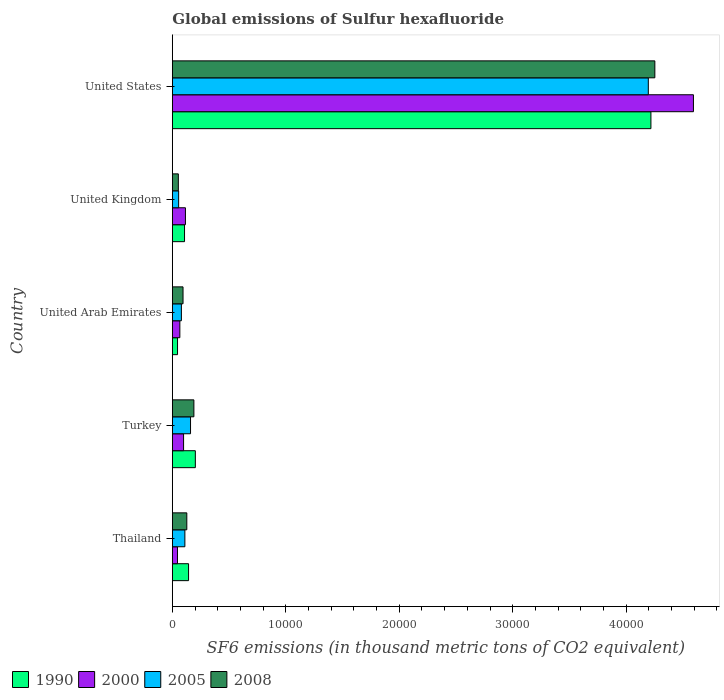How many groups of bars are there?
Your response must be concise. 5. Are the number of bars per tick equal to the number of legend labels?
Keep it short and to the point. Yes. Are the number of bars on each tick of the Y-axis equal?
Offer a very short reply. Yes. How many bars are there on the 1st tick from the top?
Your response must be concise. 4. How many bars are there on the 5th tick from the bottom?
Ensure brevity in your answer.  4. In how many cases, is the number of bars for a given country not equal to the number of legend labels?
Provide a short and direct response. 0. What is the global emissions of Sulfur hexafluoride in 2008 in United States?
Ensure brevity in your answer.  4.25e+04. Across all countries, what is the maximum global emissions of Sulfur hexafluoride in 1990?
Your answer should be compact. 4.22e+04. Across all countries, what is the minimum global emissions of Sulfur hexafluoride in 2000?
Your response must be concise. 453.1. In which country was the global emissions of Sulfur hexafluoride in 1990 maximum?
Your answer should be compact. United States. In which country was the global emissions of Sulfur hexafluoride in 1990 minimum?
Your answer should be compact. United Arab Emirates. What is the total global emissions of Sulfur hexafluoride in 2005 in the graph?
Your response must be concise. 4.60e+04. What is the difference between the global emissions of Sulfur hexafluoride in 2000 in Turkey and that in United Kingdom?
Offer a terse response. -164.9. What is the difference between the global emissions of Sulfur hexafluoride in 2008 in Thailand and the global emissions of Sulfur hexafluoride in 2005 in United Kingdom?
Give a very brief answer. 720.3. What is the average global emissions of Sulfur hexafluoride in 1990 per country?
Give a very brief answer. 9433.82. What is the difference between the global emissions of Sulfur hexafluoride in 1990 and global emissions of Sulfur hexafluoride in 2005 in United Kingdom?
Your response must be concise. 519.7. What is the ratio of the global emissions of Sulfur hexafluoride in 2008 in Turkey to that in United Arab Emirates?
Keep it short and to the point. 2.02. What is the difference between the highest and the second highest global emissions of Sulfur hexafluoride in 2000?
Offer a very short reply. 4.48e+04. What is the difference between the highest and the lowest global emissions of Sulfur hexafluoride in 2005?
Ensure brevity in your answer.  4.14e+04. In how many countries, is the global emissions of Sulfur hexafluoride in 2005 greater than the average global emissions of Sulfur hexafluoride in 2005 taken over all countries?
Offer a very short reply. 1. Is the sum of the global emissions of Sulfur hexafluoride in 2005 in Thailand and Turkey greater than the maximum global emissions of Sulfur hexafluoride in 2008 across all countries?
Give a very brief answer. No. What does the 4th bar from the top in Thailand represents?
Your response must be concise. 1990. What does the 2nd bar from the bottom in Turkey represents?
Keep it short and to the point. 2000. How many bars are there?
Provide a short and direct response. 20. How many countries are there in the graph?
Your response must be concise. 5. Are the values on the major ticks of X-axis written in scientific E-notation?
Provide a succinct answer. No. Does the graph contain grids?
Offer a terse response. No. How many legend labels are there?
Provide a short and direct response. 4. What is the title of the graph?
Your answer should be very brief. Global emissions of Sulfur hexafluoride. Does "1984" appear as one of the legend labels in the graph?
Give a very brief answer. No. What is the label or title of the X-axis?
Keep it short and to the point. SF6 emissions (in thousand metric tons of CO2 equivalent). What is the label or title of the Y-axis?
Your answer should be very brief. Country. What is the SF6 emissions (in thousand metric tons of CO2 equivalent) in 1990 in Thailand?
Provide a succinct answer. 1429.5. What is the SF6 emissions (in thousand metric tons of CO2 equivalent) in 2000 in Thailand?
Offer a terse response. 453.1. What is the SF6 emissions (in thousand metric tons of CO2 equivalent) in 2005 in Thailand?
Provide a succinct answer. 1103.9. What is the SF6 emissions (in thousand metric tons of CO2 equivalent) of 2008 in Thailand?
Offer a very short reply. 1274.5. What is the SF6 emissions (in thousand metric tons of CO2 equivalent) of 1990 in Turkey?
Give a very brief answer. 2027.1. What is the SF6 emissions (in thousand metric tons of CO2 equivalent) of 2000 in Turkey?
Offer a terse response. 989.2. What is the SF6 emissions (in thousand metric tons of CO2 equivalent) in 2005 in Turkey?
Offer a terse response. 1602.2. What is the SF6 emissions (in thousand metric tons of CO2 equivalent) in 2008 in Turkey?
Provide a short and direct response. 1898.8. What is the SF6 emissions (in thousand metric tons of CO2 equivalent) of 1990 in United Arab Emirates?
Ensure brevity in your answer.  456.1. What is the SF6 emissions (in thousand metric tons of CO2 equivalent) of 2000 in United Arab Emirates?
Offer a terse response. 660.1. What is the SF6 emissions (in thousand metric tons of CO2 equivalent) of 2005 in United Arab Emirates?
Offer a very short reply. 796.2. What is the SF6 emissions (in thousand metric tons of CO2 equivalent) in 2008 in United Arab Emirates?
Offer a very short reply. 941.4. What is the SF6 emissions (in thousand metric tons of CO2 equivalent) in 1990 in United Kingdom?
Give a very brief answer. 1073.9. What is the SF6 emissions (in thousand metric tons of CO2 equivalent) of 2000 in United Kingdom?
Provide a succinct answer. 1154.1. What is the SF6 emissions (in thousand metric tons of CO2 equivalent) of 2005 in United Kingdom?
Keep it short and to the point. 554.2. What is the SF6 emissions (in thousand metric tons of CO2 equivalent) in 2008 in United Kingdom?
Provide a succinct answer. 528.9. What is the SF6 emissions (in thousand metric tons of CO2 equivalent) of 1990 in United States?
Offer a very short reply. 4.22e+04. What is the SF6 emissions (in thousand metric tons of CO2 equivalent) of 2000 in United States?
Ensure brevity in your answer.  4.59e+04. What is the SF6 emissions (in thousand metric tons of CO2 equivalent) of 2005 in United States?
Make the answer very short. 4.20e+04. What is the SF6 emissions (in thousand metric tons of CO2 equivalent) in 2008 in United States?
Your answer should be compact. 4.25e+04. Across all countries, what is the maximum SF6 emissions (in thousand metric tons of CO2 equivalent) in 1990?
Provide a short and direct response. 4.22e+04. Across all countries, what is the maximum SF6 emissions (in thousand metric tons of CO2 equivalent) of 2000?
Provide a succinct answer. 4.59e+04. Across all countries, what is the maximum SF6 emissions (in thousand metric tons of CO2 equivalent) of 2005?
Offer a terse response. 4.20e+04. Across all countries, what is the maximum SF6 emissions (in thousand metric tons of CO2 equivalent) in 2008?
Keep it short and to the point. 4.25e+04. Across all countries, what is the minimum SF6 emissions (in thousand metric tons of CO2 equivalent) in 1990?
Provide a short and direct response. 456.1. Across all countries, what is the minimum SF6 emissions (in thousand metric tons of CO2 equivalent) of 2000?
Ensure brevity in your answer.  453.1. Across all countries, what is the minimum SF6 emissions (in thousand metric tons of CO2 equivalent) of 2005?
Provide a succinct answer. 554.2. Across all countries, what is the minimum SF6 emissions (in thousand metric tons of CO2 equivalent) of 2008?
Offer a very short reply. 528.9. What is the total SF6 emissions (in thousand metric tons of CO2 equivalent) of 1990 in the graph?
Ensure brevity in your answer.  4.72e+04. What is the total SF6 emissions (in thousand metric tons of CO2 equivalent) in 2000 in the graph?
Give a very brief answer. 4.92e+04. What is the total SF6 emissions (in thousand metric tons of CO2 equivalent) of 2005 in the graph?
Ensure brevity in your answer.  4.60e+04. What is the total SF6 emissions (in thousand metric tons of CO2 equivalent) of 2008 in the graph?
Your response must be concise. 4.72e+04. What is the difference between the SF6 emissions (in thousand metric tons of CO2 equivalent) in 1990 in Thailand and that in Turkey?
Provide a succinct answer. -597.6. What is the difference between the SF6 emissions (in thousand metric tons of CO2 equivalent) of 2000 in Thailand and that in Turkey?
Provide a short and direct response. -536.1. What is the difference between the SF6 emissions (in thousand metric tons of CO2 equivalent) of 2005 in Thailand and that in Turkey?
Your response must be concise. -498.3. What is the difference between the SF6 emissions (in thousand metric tons of CO2 equivalent) in 2008 in Thailand and that in Turkey?
Make the answer very short. -624.3. What is the difference between the SF6 emissions (in thousand metric tons of CO2 equivalent) of 1990 in Thailand and that in United Arab Emirates?
Give a very brief answer. 973.4. What is the difference between the SF6 emissions (in thousand metric tons of CO2 equivalent) of 2000 in Thailand and that in United Arab Emirates?
Provide a short and direct response. -207. What is the difference between the SF6 emissions (in thousand metric tons of CO2 equivalent) of 2005 in Thailand and that in United Arab Emirates?
Keep it short and to the point. 307.7. What is the difference between the SF6 emissions (in thousand metric tons of CO2 equivalent) in 2008 in Thailand and that in United Arab Emirates?
Provide a short and direct response. 333.1. What is the difference between the SF6 emissions (in thousand metric tons of CO2 equivalent) in 1990 in Thailand and that in United Kingdom?
Offer a very short reply. 355.6. What is the difference between the SF6 emissions (in thousand metric tons of CO2 equivalent) of 2000 in Thailand and that in United Kingdom?
Ensure brevity in your answer.  -701. What is the difference between the SF6 emissions (in thousand metric tons of CO2 equivalent) in 2005 in Thailand and that in United Kingdom?
Offer a very short reply. 549.7. What is the difference between the SF6 emissions (in thousand metric tons of CO2 equivalent) in 2008 in Thailand and that in United Kingdom?
Keep it short and to the point. 745.6. What is the difference between the SF6 emissions (in thousand metric tons of CO2 equivalent) of 1990 in Thailand and that in United States?
Ensure brevity in your answer.  -4.08e+04. What is the difference between the SF6 emissions (in thousand metric tons of CO2 equivalent) in 2000 in Thailand and that in United States?
Your answer should be compact. -4.55e+04. What is the difference between the SF6 emissions (in thousand metric tons of CO2 equivalent) in 2005 in Thailand and that in United States?
Your response must be concise. -4.08e+04. What is the difference between the SF6 emissions (in thousand metric tons of CO2 equivalent) of 2008 in Thailand and that in United States?
Your answer should be very brief. -4.13e+04. What is the difference between the SF6 emissions (in thousand metric tons of CO2 equivalent) in 1990 in Turkey and that in United Arab Emirates?
Your response must be concise. 1571. What is the difference between the SF6 emissions (in thousand metric tons of CO2 equivalent) in 2000 in Turkey and that in United Arab Emirates?
Offer a very short reply. 329.1. What is the difference between the SF6 emissions (in thousand metric tons of CO2 equivalent) of 2005 in Turkey and that in United Arab Emirates?
Make the answer very short. 806. What is the difference between the SF6 emissions (in thousand metric tons of CO2 equivalent) in 2008 in Turkey and that in United Arab Emirates?
Ensure brevity in your answer.  957.4. What is the difference between the SF6 emissions (in thousand metric tons of CO2 equivalent) of 1990 in Turkey and that in United Kingdom?
Your answer should be very brief. 953.2. What is the difference between the SF6 emissions (in thousand metric tons of CO2 equivalent) in 2000 in Turkey and that in United Kingdom?
Keep it short and to the point. -164.9. What is the difference between the SF6 emissions (in thousand metric tons of CO2 equivalent) in 2005 in Turkey and that in United Kingdom?
Provide a succinct answer. 1048. What is the difference between the SF6 emissions (in thousand metric tons of CO2 equivalent) in 2008 in Turkey and that in United Kingdom?
Make the answer very short. 1369.9. What is the difference between the SF6 emissions (in thousand metric tons of CO2 equivalent) of 1990 in Turkey and that in United States?
Make the answer very short. -4.02e+04. What is the difference between the SF6 emissions (in thousand metric tons of CO2 equivalent) in 2000 in Turkey and that in United States?
Give a very brief answer. -4.49e+04. What is the difference between the SF6 emissions (in thousand metric tons of CO2 equivalent) in 2005 in Turkey and that in United States?
Give a very brief answer. -4.04e+04. What is the difference between the SF6 emissions (in thousand metric tons of CO2 equivalent) in 2008 in Turkey and that in United States?
Provide a succinct answer. -4.06e+04. What is the difference between the SF6 emissions (in thousand metric tons of CO2 equivalent) of 1990 in United Arab Emirates and that in United Kingdom?
Keep it short and to the point. -617.8. What is the difference between the SF6 emissions (in thousand metric tons of CO2 equivalent) in 2000 in United Arab Emirates and that in United Kingdom?
Your response must be concise. -494. What is the difference between the SF6 emissions (in thousand metric tons of CO2 equivalent) in 2005 in United Arab Emirates and that in United Kingdom?
Offer a terse response. 242. What is the difference between the SF6 emissions (in thousand metric tons of CO2 equivalent) of 2008 in United Arab Emirates and that in United Kingdom?
Your answer should be very brief. 412.5. What is the difference between the SF6 emissions (in thousand metric tons of CO2 equivalent) of 1990 in United Arab Emirates and that in United States?
Offer a very short reply. -4.17e+04. What is the difference between the SF6 emissions (in thousand metric tons of CO2 equivalent) of 2000 in United Arab Emirates and that in United States?
Provide a short and direct response. -4.53e+04. What is the difference between the SF6 emissions (in thousand metric tons of CO2 equivalent) of 2005 in United Arab Emirates and that in United States?
Provide a succinct answer. -4.12e+04. What is the difference between the SF6 emissions (in thousand metric tons of CO2 equivalent) of 2008 in United Arab Emirates and that in United States?
Your answer should be compact. -4.16e+04. What is the difference between the SF6 emissions (in thousand metric tons of CO2 equivalent) in 1990 in United Kingdom and that in United States?
Offer a terse response. -4.11e+04. What is the difference between the SF6 emissions (in thousand metric tons of CO2 equivalent) of 2000 in United Kingdom and that in United States?
Provide a short and direct response. -4.48e+04. What is the difference between the SF6 emissions (in thousand metric tons of CO2 equivalent) of 2005 in United Kingdom and that in United States?
Your response must be concise. -4.14e+04. What is the difference between the SF6 emissions (in thousand metric tons of CO2 equivalent) of 2008 in United Kingdom and that in United States?
Offer a terse response. -4.20e+04. What is the difference between the SF6 emissions (in thousand metric tons of CO2 equivalent) in 1990 in Thailand and the SF6 emissions (in thousand metric tons of CO2 equivalent) in 2000 in Turkey?
Your response must be concise. 440.3. What is the difference between the SF6 emissions (in thousand metric tons of CO2 equivalent) in 1990 in Thailand and the SF6 emissions (in thousand metric tons of CO2 equivalent) in 2005 in Turkey?
Offer a terse response. -172.7. What is the difference between the SF6 emissions (in thousand metric tons of CO2 equivalent) of 1990 in Thailand and the SF6 emissions (in thousand metric tons of CO2 equivalent) of 2008 in Turkey?
Provide a short and direct response. -469.3. What is the difference between the SF6 emissions (in thousand metric tons of CO2 equivalent) in 2000 in Thailand and the SF6 emissions (in thousand metric tons of CO2 equivalent) in 2005 in Turkey?
Provide a succinct answer. -1149.1. What is the difference between the SF6 emissions (in thousand metric tons of CO2 equivalent) of 2000 in Thailand and the SF6 emissions (in thousand metric tons of CO2 equivalent) of 2008 in Turkey?
Your answer should be very brief. -1445.7. What is the difference between the SF6 emissions (in thousand metric tons of CO2 equivalent) of 2005 in Thailand and the SF6 emissions (in thousand metric tons of CO2 equivalent) of 2008 in Turkey?
Your answer should be very brief. -794.9. What is the difference between the SF6 emissions (in thousand metric tons of CO2 equivalent) of 1990 in Thailand and the SF6 emissions (in thousand metric tons of CO2 equivalent) of 2000 in United Arab Emirates?
Your answer should be very brief. 769.4. What is the difference between the SF6 emissions (in thousand metric tons of CO2 equivalent) of 1990 in Thailand and the SF6 emissions (in thousand metric tons of CO2 equivalent) of 2005 in United Arab Emirates?
Keep it short and to the point. 633.3. What is the difference between the SF6 emissions (in thousand metric tons of CO2 equivalent) in 1990 in Thailand and the SF6 emissions (in thousand metric tons of CO2 equivalent) in 2008 in United Arab Emirates?
Your response must be concise. 488.1. What is the difference between the SF6 emissions (in thousand metric tons of CO2 equivalent) of 2000 in Thailand and the SF6 emissions (in thousand metric tons of CO2 equivalent) of 2005 in United Arab Emirates?
Your answer should be compact. -343.1. What is the difference between the SF6 emissions (in thousand metric tons of CO2 equivalent) of 2000 in Thailand and the SF6 emissions (in thousand metric tons of CO2 equivalent) of 2008 in United Arab Emirates?
Your answer should be very brief. -488.3. What is the difference between the SF6 emissions (in thousand metric tons of CO2 equivalent) in 2005 in Thailand and the SF6 emissions (in thousand metric tons of CO2 equivalent) in 2008 in United Arab Emirates?
Give a very brief answer. 162.5. What is the difference between the SF6 emissions (in thousand metric tons of CO2 equivalent) in 1990 in Thailand and the SF6 emissions (in thousand metric tons of CO2 equivalent) in 2000 in United Kingdom?
Provide a short and direct response. 275.4. What is the difference between the SF6 emissions (in thousand metric tons of CO2 equivalent) in 1990 in Thailand and the SF6 emissions (in thousand metric tons of CO2 equivalent) in 2005 in United Kingdom?
Offer a very short reply. 875.3. What is the difference between the SF6 emissions (in thousand metric tons of CO2 equivalent) in 1990 in Thailand and the SF6 emissions (in thousand metric tons of CO2 equivalent) in 2008 in United Kingdom?
Give a very brief answer. 900.6. What is the difference between the SF6 emissions (in thousand metric tons of CO2 equivalent) of 2000 in Thailand and the SF6 emissions (in thousand metric tons of CO2 equivalent) of 2005 in United Kingdom?
Ensure brevity in your answer.  -101.1. What is the difference between the SF6 emissions (in thousand metric tons of CO2 equivalent) of 2000 in Thailand and the SF6 emissions (in thousand metric tons of CO2 equivalent) of 2008 in United Kingdom?
Your answer should be very brief. -75.8. What is the difference between the SF6 emissions (in thousand metric tons of CO2 equivalent) in 2005 in Thailand and the SF6 emissions (in thousand metric tons of CO2 equivalent) in 2008 in United Kingdom?
Ensure brevity in your answer.  575. What is the difference between the SF6 emissions (in thousand metric tons of CO2 equivalent) in 1990 in Thailand and the SF6 emissions (in thousand metric tons of CO2 equivalent) in 2000 in United States?
Keep it short and to the point. -4.45e+04. What is the difference between the SF6 emissions (in thousand metric tons of CO2 equivalent) in 1990 in Thailand and the SF6 emissions (in thousand metric tons of CO2 equivalent) in 2005 in United States?
Give a very brief answer. -4.05e+04. What is the difference between the SF6 emissions (in thousand metric tons of CO2 equivalent) of 1990 in Thailand and the SF6 emissions (in thousand metric tons of CO2 equivalent) of 2008 in United States?
Make the answer very short. -4.11e+04. What is the difference between the SF6 emissions (in thousand metric tons of CO2 equivalent) of 2000 in Thailand and the SF6 emissions (in thousand metric tons of CO2 equivalent) of 2005 in United States?
Make the answer very short. -4.15e+04. What is the difference between the SF6 emissions (in thousand metric tons of CO2 equivalent) in 2000 in Thailand and the SF6 emissions (in thousand metric tons of CO2 equivalent) in 2008 in United States?
Ensure brevity in your answer.  -4.21e+04. What is the difference between the SF6 emissions (in thousand metric tons of CO2 equivalent) in 2005 in Thailand and the SF6 emissions (in thousand metric tons of CO2 equivalent) in 2008 in United States?
Your response must be concise. -4.14e+04. What is the difference between the SF6 emissions (in thousand metric tons of CO2 equivalent) of 1990 in Turkey and the SF6 emissions (in thousand metric tons of CO2 equivalent) of 2000 in United Arab Emirates?
Your response must be concise. 1367. What is the difference between the SF6 emissions (in thousand metric tons of CO2 equivalent) in 1990 in Turkey and the SF6 emissions (in thousand metric tons of CO2 equivalent) in 2005 in United Arab Emirates?
Provide a succinct answer. 1230.9. What is the difference between the SF6 emissions (in thousand metric tons of CO2 equivalent) in 1990 in Turkey and the SF6 emissions (in thousand metric tons of CO2 equivalent) in 2008 in United Arab Emirates?
Provide a succinct answer. 1085.7. What is the difference between the SF6 emissions (in thousand metric tons of CO2 equivalent) of 2000 in Turkey and the SF6 emissions (in thousand metric tons of CO2 equivalent) of 2005 in United Arab Emirates?
Your answer should be compact. 193. What is the difference between the SF6 emissions (in thousand metric tons of CO2 equivalent) of 2000 in Turkey and the SF6 emissions (in thousand metric tons of CO2 equivalent) of 2008 in United Arab Emirates?
Offer a very short reply. 47.8. What is the difference between the SF6 emissions (in thousand metric tons of CO2 equivalent) in 2005 in Turkey and the SF6 emissions (in thousand metric tons of CO2 equivalent) in 2008 in United Arab Emirates?
Your response must be concise. 660.8. What is the difference between the SF6 emissions (in thousand metric tons of CO2 equivalent) of 1990 in Turkey and the SF6 emissions (in thousand metric tons of CO2 equivalent) of 2000 in United Kingdom?
Your answer should be very brief. 873. What is the difference between the SF6 emissions (in thousand metric tons of CO2 equivalent) in 1990 in Turkey and the SF6 emissions (in thousand metric tons of CO2 equivalent) in 2005 in United Kingdom?
Offer a very short reply. 1472.9. What is the difference between the SF6 emissions (in thousand metric tons of CO2 equivalent) of 1990 in Turkey and the SF6 emissions (in thousand metric tons of CO2 equivalent) of 2008 in United Kingdom?
Ensure brevity in your answer.  1498.2. What is the difference between the SF6 emissions (in thousand metric tons of CO2 equivalent) of 2000 in Turkey and the SF6 emissions (in thousand metric tons of CO2 equivalent) of 2005 in United Kingdom?
Your answer should be compact. 435. What is the difference between the SF6 emissions (in thousand metric tons of CO2 equivalent) of 2000 in Turkey and the SF6 emissions (in thousand metric tons of CO2 equivalent) of 2008 in United Kingdom?
Your answer should be compact. 460.3. What is the difference between the SF6 emissions (in thousand metric tons of CO2 equivalent) in 2005 in Turkey and the SF6 emissions (in thousand metric tons of CO2 equivalent) in 2008 in United Kingdom?
Give a very brief answer. 1073.3. What is the difference between the SF6 emissions (in thousand metric tons of CO2 equivalent) in 1990 in Turkey and the SF6 emissions (in thousand metric tons of CO2 equivalent) in 2000 in United States?
Your answer should be very brief. -4.39e+04. What is the difference between the SF6 emissions (in thousand metric tons of CO2 equivalent) in 1990 in Turkey and the SF6 emissions (in thousand metric tons of CO2 equivalent) in 2005 in United States?
Provide a short and direct response. -3.99e+04. What is the difference between the SF6 emissions (in thousand metric tons of CO2 equivalent) in 1990 in Turkey and the SF6 emissions (in thousand metric tons of CO2 equivalent) in 2008 in United States?
Provide a succinct answer. -4.05e+04. What is the difference between the SF6 emissions (in thousand metric tons of CO2 equivalent) in 2000 in Turkey and the SF6 emissions (in thousand metric tons of CO2 equivalent) in 2005 in United States?
Ensure brevity in your answer.  -4.10e+04. What is the difference between the SF6 emissions (in thousand metric tons of CO2 equivalent) in 2000 in Turkey and the SF6 emissions (in thousand metric tons of CO2 equivalent) in 2008 in United States?
Keep it short and to the point. -4.15e+04. What is the difference between the SF6 emissions (in thousand metric tons of CO2 equivalent) in 2005 in Turkey and the SF6 emissions (in thousand metric tons of CO2 equivalent) in 2008 in United States?
Provide a succinct answer. -4.09e+04. What is the difference between the SF6 emissions (in thousand metric tons of CO2 equivalent) of 1990 in United Arab Emirates and the SF6 emissions (in thousand metric tons of CO2 equivalent) of 2000 in United Kingdom?
Provide a short and direct response. -698. What is the difference between the SF6 emissions (in thousand metric tons of CO2 equivalent) of 1990 in United Arab Emirates and the SF6 emissions (in thousand metric tons of CO2 equivalent) of 2005 in United Kingdom?
Your answer should be very brief. -98.1. What is the difference between the SF6 emissions (in thousand metric tons of CO2 equivalent) in 1990 in United Arab Emirates and the SF6 emissions (in thousand metric tons of CO2 equivalent) in 2008 in United Kingdom?
Ensure brevity in your answer.  -72.8. What is the difference between the SF6 emissions (in thousand metric tons of CO2 equivalent) in 2000 in United Arab Emirates and the SF6 emissions (in thousand metric tons of CO2 equivalent) in 2005 in United Kingdom?
Make the answer very short. 105.9. What is the difference between the SF6 emissions (in thousand metric tons of CO2 equivalent) of 2000 in United Arab Emirates and the SF6 emissions (in thousand metric tons of CO2 equivalent) of 2008 in United Kingdom?
Make the answer very short. 131.2. What is the difference between the SF6 emissions (in thousand metric tons of CO2 equivalent) of 2005 in United Arab Emirates and the SF6 emissions (in thousand metric tons of CO2 equivalent) of 2008 in United Kingdom?
Ensure brevity in your answer.  267.3. What is the difference between the SF6 emissions (in thousand metric tons of CO2 equivalent) in 1990 in United Arab Emirates and the SF6 emissions (in thousand metric tons of CO2 equivalent) in 2000 in United States?
Give a very brief answer. -4.55e+04. What is the difference between the SF6 emissions (in thousand metric tons of CO2 equivalent) in 1990 in United Arab Emirates and the SF6 emissions (in thousand metric tons of CO2 equivalent) in 2005 in United States?
Your response must be concise. -4.15e+04. What is the difference between the SF6 emissions (in thousand metric tons of CO2 equivalent) of 1990 in United Arab Emirates and the SF6 emissions (in thousand metric tons of CO2 equivalent) of 2008 in United States?
Make the answer very short. -4.21e+04. What is the difference between the SF6 emissions (in thousand metric tons of CO2 equivalent) of 2000 in United Arab Emirates and the SF6 emissions (in thousand metric tons of CO2 equivalent) of 2005 in United States?
Ensure brevity in your answer.  -4.13e+04. What is the difference between the SF6 emissions (in thousand metric tons of CO2 equivalent) of 2000 in United Arab Emirates and the SF6 emissions (in thousand metric tons of CO2 equivalent) of 2008 in United States?
Keep it short and to the point. -4.19e+04. What is the difference between the SF6 emissions (in thousand metric tons of CO2 equivalent) of 2005 in United Arab Emirates and the SF6 emissions (in thousand metric tons of CO2 equivalent) of 2008 in United States?
Offer a terse response. -4.17e+04. What is the difference between the SF6 emissions (in thousand metric tons of CO2 equivalent) in 1990 in United Kingdom and the SF6 emissions (in thousand metric tons of CO2 equivalent) in 2000 in United States?
Make the answer very short. -4.49e+04. What is the difference between the SF6 emissions (in thousand metric tons of CO2 equivalent) in 1990 in United Kingdom and the SF6 emissions (in thousand metric tons of CO2 equivalent) in 2005 in United States?
Give a very brief answer. -4.09e+04. What is the difference between the SF6 emissions (in thousand metric tons of CO2 equivalent) in 1990 in United Kingdom and the SF6 emissions (in thousand metric tons of CO2 equivalent) in 2008 in United States?
Your answer should be compact. -4.15e+04. What is the difference between the SF6 emissions (in thousand metric tons of CO2 equivalent) in 2000 in United Kingdom and the SF6 emissions (in thousand metric tons of CO2 equivalent) in 2005 in United States?
Give a very brief answer. -4.08e+04. What is the difference between the SF6 emissions (in thousand metric tons of CO2 equivalent) of 2000 in United Kingdom and the SF6 emissions (in thousand metric tons of CO2 equivalent) of 2008 in United States?
Offer a terse response. -4.14e+04. What is the difference between the SF6 emissions (in thousand metric tons of CO2 equivalent) in 2005 in United Kingdom and the SF6 emissions (in thousand metric tons of CO2 equivalent) in 2008 in United States?
Offer a very short reply. -4.20e+04. What is the average SF6 emissions (in thousand metric tons of CO2 equivalent) of 1990 per country?
Keep it short and to the point. 9433.82. What is the average SF6 emissions (in thousand metric tons of CO2 equivalent) in 2000 per country?
Provide a short and direct response. 9837.32. What is the average SF6 emissions (in thousand metric tons of CO2 equivalent) in 2005 per country?
Offer a terse response. 9201.88. What is the average SF6 emissions (in thousand metric tons of CO2 equivalent) of 2008 per country?
Give a very brief answer. 9434.44. What is the difference between the SF6 emissions (in thousand metric tons of CO2 equivalent) in 1990 and SF6 emissions (in thousand metric tons of CO2 equivalent) in 2000 in Thailand?
Your response must be concise. 976.4. What is the difference between the SF6 emissions (in thousand metric tons of CO2 equivalent) of 1990 and SF6 emissions (in thousand metric tons of CO2 equivalent) of 2005 in Thailand?
Offer a terse response. 325.6. What is the difference between the SF6 emissions (in thousand metric tons of CO2 equivalent) in 1990 and SF6 emissions (in thousand metric tons of CO2 equivalent) in 2008 in Thailand?
Your response must be concise. 155. What is the difference between the SF6 emissions (in thousand metric tons of CO2 equivalent) in 2000 and SF6 emissions (in thousand metric tons of CO2 equivalent) in 2005 in Thailand?
Make the answer very short. -650.8. What is the difference between the SF6 emissions (in thousand metric tons of CO2 equivalent) of 2000 and SF6 emissions (in thousand metric tons of CO2 equivalent) of 2008 in Thailand?
Keep it short and to the point. -821.4. What is the difference between the SF6 emissions (in thousand metric tons of CO2 equivalent) of 2005 and SF6 emissions (in thousand metric tons of CO2 equivalent) of 2008 in Thailand?
Your answer should be compact. -170.6. What is the difference between the SF6 emissions (in thousand metric tons of CO2 equivalent) of 1990 and SF6 emissions (in thousand metric tons of CO2 equivalent) of 2000 in Turkey?
Keep it short and to the point. 1037.9. What is the difference between the SF6 emissions (in thousand metric tons of CO2 equivalent) in 1990 and SF6 emissions (in thousand metric tons of CO2 equivalent) in 2005 in Turkey?
Keep it short and to the point. 424.9. What is the difference between the SF6 emissions (in thousand metric tons of CO2 equivalent) of 1990 and SF6 emissions (in thousand metric tons of CO2 equivalent) of 2008 in Turkey?
Provide a short and direct response. 128.3. What is the difference between the SF6 emissions (in thousand metric tons of CO2 equivalent) of 2000 and SF6 emissions (in thousand metric tons of CO2 equivalent) of 2005 in Turkey?
Offer a terse response. -613. What is the difference between the SF6 emissions (in thousand metric tons of CO2 equivalent) of 2000 and SF6 emissions (in thousand metric tons of CO2 equivalent) of 2008 in Turkey?
Give a very brief answer. -909.6. What is the difference between the SF6 emissions (in thousand metric tons of CO2 equivalent) in 2005 and SF6 emissions (in thousand metric tons of CO2 equivalent) in 2008 in Turkey?
Your answer should be very brief. -296.6. What is the difference between the SF6 emissions (in thousand metric tons of CO2 equivalent) in 1990 and SF6 emissions (in thousand metric tons of CO2 equivalent) in 2000 in United Arab Emirates?
Provide a short and direct response. -204. What is the difference between the SF6 emissions (in thousand metric tons of CO2 equivalent) in 1990 and SF6 emissions (in thousand metric tons of CO2 equivalent) in 2005 in United Arab Emirates?
Provide a succinct answer. -340.1. What is the difference between the SF6 emissions (in thousand metric tons of CO2 equivalent) in 1990 and SF6 emissions (in thousand metric tons of CO2 equivalent) in 2008 in United Arab Emirates?
Provide a succinct answer. -485.3. What is the difference between the SF6 emissions (in thousand metric tons of CO2 equivalent) in 2000 and SF6 emissions (in thousand metric tons of CO2 equivalent) in 2005 in United Arab Emirates?
Provide a succinct answer. -136.1. What is the difference between the SF6 emissions (in thousand metric tons of CO2 equivalent) of 2000 and SF6 emissions (in thousand metric tons of CO2 equivalent) of 2008 in United Arab Emirates?
Provide a short and direct response. -281.3. What is the difference between the SF6 emissions (in thousand metric tons of CO2 equivalent) of 2005 and SF6 emissions (in thousand metric tons of CO2 equivalent) of 2008 in United Arab Emirates?
Offer a very short reply. -145.2. What is the difference between the SF6 emissions (in thousand metric tons of CO2 equivalent) in 1990 and SF6 emissions (in thousand metric tons of CO2 equivalent) in 2000 in United Kingdom?
Offer a very short reply. -80.2. What is the difference between the SF6 emissions (in thousand metric tons of CO2 equivalent) of 1990 and SF6 emissions (in thousand metric tons of CO2 equivalent) of 2005 in United Kingdom?
Provide a short and direct response. 519.7. What is the difference between the SF6 emissions (in thousand metric tons of CO2 equivalent) in 1990 and SF6 emissions (in thousand metric tons of CO2 equivalent) in 2008 in United Kingdom?
Provide a succinct answer. 545. What is the difference between the SF6 emissions (in thousand metric tons of CO2 equivalent) in 2000 and SF6 emissions (in thousand metric tons of CO2 equivalent) in 2005 in United Kingdom?
Keep it short and to the point. 599.9. What is the difference between the SF6 emissions (in thousand metric tons of CO2 equivalent) in 2000 and SF6 emissions (in thousand metric tons of CO2 equivalent) in 2008 in United Kingdom?
Give a very brief answer. 625.2. What is the difference between the SF6 emissions (in thousand metric tons of CO2 equivalent) of 2005 and SF6 emissions (in thousand metric tons of CO2 equivalent) of 2008 in United Kingdom?
Your answer should be very brief. 25.3. What is the difference between the SF6 emissions (in thousand metric tons of CO2 equivalent) of 1990 and SF6 emissions (in thousand metric tons of CO2 equivalent) of 2000 in United States?
Offer a terse response. -3747.6. What is the difference between the SF6 emissions (in thousand metric tons of CO2 equivalent) of 1990 and SF6 emissions (in thousand metric tons of CO2 equivalent) of 2005 in United States?
Your answer should be very brief. 229.6. What is the difference between the SF6 emissions (in thousand metric tons of CO2 equivalent) in 1990 and SF6 emissions (in thousand metric tons of CO2 equivalent) in 2008 in United States?
Offer a terse response. -346.1. What is the difference between the SF6 emissions (in thousand metric tons of CO2 equivalent) of 2000 and SF6 emissions (in thousand metric tons of CO2 equivalent) of 2005 in United States?
Give a very brief answer. 3977.2. What is the difference between the SF6 emissions (in thousand metric tons of CO2 equivalent) of 2000 and SF6 emissions (in thousand metric tons of CO2 equivalent) of 2008 in United States?
Your answer should be compact. 3401.5. What is the difference between the SF6 emissions (in thousand metric tons of CO2 equivalent) of 2005 and SF6 emissions (in thousand metric tons of CO2 equivalent) of 2008 in United States?
Offer a very short reply. -575.7. What is the ratio of the SF6 emissions (in thousand metric tons of CO2 equivalent) of 1990 in Thailand to that in Turkey?
Give a very brief answer. 0.71. What is the ratio of the SF6 emissions (in thousand metric tons of CO2 equivalent) in 2000 in Thailand to that in Turkey?
Give a very brief answer. 0.46. What is the ratio of the SF6 emissions (in thousand metric tons of CO2 equivalent) of 2005 in Thailand to that in Turkey?
Keep it short and to the point. 0.69. What is the ratio of the SF6 emissions (in thousand metric tons of CO2 equivalent) of 2008 in Thailand to that in Turkey?
Your response must be concise. 0.67. What is the ratio of the SF6 emissions (in thousand metric tons of CO2 equivalent) of 1990 in Thailand to that in United Arab Emirates?
Keep it short and to the point. 3.13. What is the ratio of the SF6 emissions (in thousand metric tons of CO2 equivalent) of 2000 in Thailand to that in United Arab Emirates?
Give a very brief answer. 0.69. What is the ratio of the SF6 emissions (in thousand metric tons of CO2 equivalent) in 2005 in Thailand to that in United Arab Emirates?
Offer a terse response. 1.39. What is the ratio of the SF6 emissions (in thousand metric tons of CO2 equivalent) of 2008 in Thailand to that in United Arab Emirates?
Offer a very short reply. 1.35. What is the ratio of the SF6 emissions (in thousand metric tons of CO2 equivalent) of 1990 in Thailand to that in United Kingdom?
Make the answer very short. 1.33. What is the ratio of the SF6 emissions (in thousand metric tons of CO2 equivalent) in 2000 in Thailand to that in United Kingdom?
Give a very brief answer. 0.39. What is the ratio of the SF6 emissions (in thousand metric tons of CO2 equivalent) in 2005 in Thailand to that in United Kingdom?
Make the answer very short. 1.99. What is the ratio of the SF6 emissions (in thousand metric tons of CO2 equivalent) in 2008 in Thailand to that in United Kingdom?
Provide a succinct answer. 2.41. What is the ratio of the SF6 emissions (in thousand metric tons of CO2 equivalent) in 1990 in Thailand to that in United States?
Offer a terse response. 0.03. What is the ratio of the SF6 emissions (in thousand metric tons of CO2 equivalent) in 2000 in Thailand to that in United States?
Ensure brevity in your answer.  0.01. What is the ratio of the SF6 emissions (in thousand metric tons of CO2 equivalent) in 2005 in Thailand to that in United States?
Your response must be concise. 0.03. What is the ratio of the SF6 emissions (in thousand metric tons of CO2 equivalent) in 1990 in Turkey to that in United Arab Emirates?
Your answer should be compact. 4.44. What is the ratio of the SF6 emissions (in thousand metric tons of CO2 equivalent) of 2000 in Turkey to that in United Arab Emirates?
Offer a terse response. 1.5. What is the ratio of the SF6 emissions (in thousand metric tons of CO2 equivalent) of 2005 in Turkey to that in United Arab Emirates?
Keep it short and to the point. 2.01. What is the ratio of the SF6 emissions (in thousand metric tons of CO2 equivalent) of 2008 in Turkey to that in United Arab Emirates?
Offer a terse response. 2.02. What is the ratio of the SF6 emissions (in thousand metric tons of CO2 equivalent) of 1990 in Turkey to that in United Kingdom?
Provide a short and direct response. 1.89. What is the ratio of the SF6 emissions (in thousand metric tons of CO2 equivalent) of 2005 in Turkey to that in United Kingdom?
Your answer should be compact. 2.89. What is the ratio of the SF6 emissions (in thousand metric tons of CO2 equivalent) in 2008 in Turkey to that in United Kingdom?
Your response must be concise. 3.59. What is the ratio of the SF6 emissions (in thousand metric tons of CO2 equivalent) of 1990 in Turkey to that in United States?
Provide a succinct answer. 0.05. What is the ratio of the SF6 emissions (in thousand metric tons of CO2 equivalent) of 2000 in Turkey to that in United States?
Your response must be concise. 0.02. What is the ratio of the SF6 emissions (in thousand metric tons of CO2 equivalent) in 2005 in Turkey to that in United States?
Offer a terse response. 0.04. What is the ratio of the SF6 emissions (in thousand metric tons of CO2 equivalent) of 2008 in Turkey to that in United States?
Give a very brief answer. 0.04. What is the ratio of the SF6 emissions (in thousand metric tons of CO2 equivalent) of 1990 in United Arab Emirates to that in United Kingdom?
Offer a very short reply. 0.42. What is the ratio of the SF6 emissions (in thousand metric tons of CO2 equivalent) in 2000 in United Arab Emirates to that in United Kingdom?
Provide a short and direct response. 0.57. What is the ratio of the SF6 emissions (in thousand metric tons of CO2 equivalent) of 2005 in United Arab Emirates to that in United Kingdom?
Offer a terse response. 1.44. What is the ratio of the SF6 emissions (in thousand metric tons of CO2 equivalent) in 2008 in United Arab Emirates to that in United Kingdom?
Your answer should be very brief. 1.78. What is the ratio of the SF6 emissions (in thousand metric tons of CO2 equivalent) of 1990 in United Arab Emirates to that in United States?
Ensure brevity in your answer.  0.01. What is the ratio of the SF6 emissions (in thousand metric tons of CO2 equivalent) in 2000 in United Arab Emirates to that in United States?
Give a very brief answer. 0.01. What is the ratio of the SF6 emissions (in thousand metric tons of CO2 equivalent) in 2005 in United Arab Emirates to that in United States?
Keep it short and to the point. 0.02. What is the ratio of the SF6 emissions (in thousand metric tons of CO2 equivalent) of 2008 in United Arab Emirates to that in United States?
Make the answer very short. 0.02. What is the ratio of the SF6 emissions (in thousand metric tons of CO2 equivalent) in 1990 in United Kingdom to that in United States?
Offer a very short reply. 0.03. What is the ratio of the SF6 emissions (in thousand metric tons of CO2 equivalent) in 2000 in United Kingdom to that in United States?
Your answer should be compact. 0.03. What is the ratio of the SF6 emissions (in thousand metric tons of CO2 equivalent) of 2005 in United Kingdom to that in United States?
Ensure brevity in your answer.  0.01. What is the ratio of the SF6 emissions (in thousand metric tons of CO2 equivalent) in 2008 in United Kingdom to that in United States?
Provide a short and direct response. 0.01. What is the difference between the highest and the second highest SF6 emissions (in thousand metric tons of CO2 equivalent) in 1990?
Your response must be concise. 4.02e+04. What is the difference between the highest and the second highest SF6 emissions (in thousand metric tons of CO2 equivalent) of 2000?
Offer a very short reply. 4.48e+04. What is the difference between the highest and the second highest SF6 emissions (in thousand metric tons of CO2 equivalent) in 2005?
Your answer should be compact. 4.04e+04. What is the difference between the highest and the second highest SF6 emissions (in thousand metric tons of CO2 equivalent) of 2008?
Your answer should be very brief. 4.06e+04. What is the difference between the highest and the lowest SF6 emissions (in thousand metric tons of CO2 equivalent) of 1990?
Your answer should be compact. 4.17e+04. What is the difference between the highest and the lowest SF6 emissions (in thousand metric tons of CO2 equivalent) in 2000?
Make the answer very short. 4.55e+04. What is the difference between the highest and the lowest SF6 emissions (in thousand metric tons of CO2 equivalent) in 2005?
Offer a very short reply. 4.14e+04. What is the difference between the highest and the lowest SF6 emissions (in thousand metric tons of CO2 equivalent) in 2008?
Offer a very short reply. 4.20e+04. 